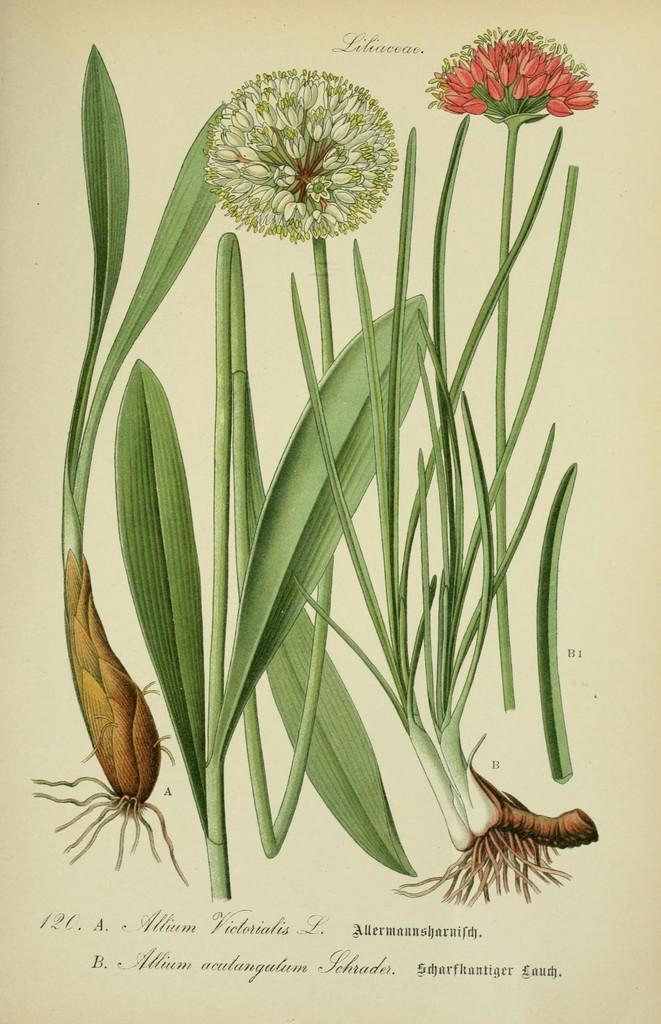Please provide a concise description of this image. In this picture there are pictures of plants and flowers on the on the paper. At the bottom there is text. 